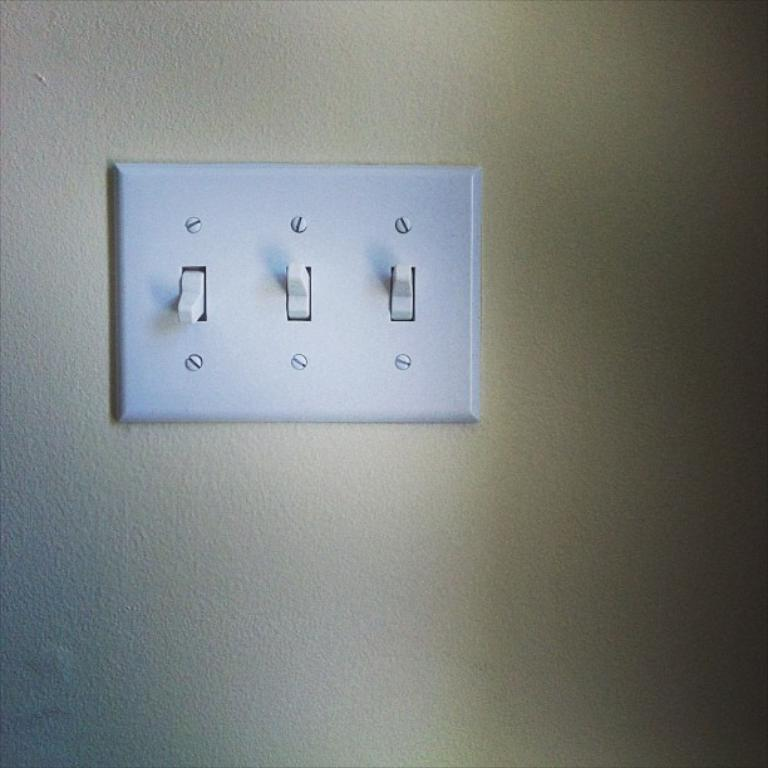What is the main object in the middle of the image? There is a switchboard in the middle of the image. Where is the switchboard located? The switchboard is on the wall. What is the color of the switchboard? The switchboard is white in color. What features can be seen on the switchboard? There are switches and screws on the switchboard. What type of sail can be seen on the switchboard in the image? There is no sail present on the switchboard in the image. Can you tell me how many receipts are attached to the switchboard? There are no receipts attached to the switchboard in the image. 